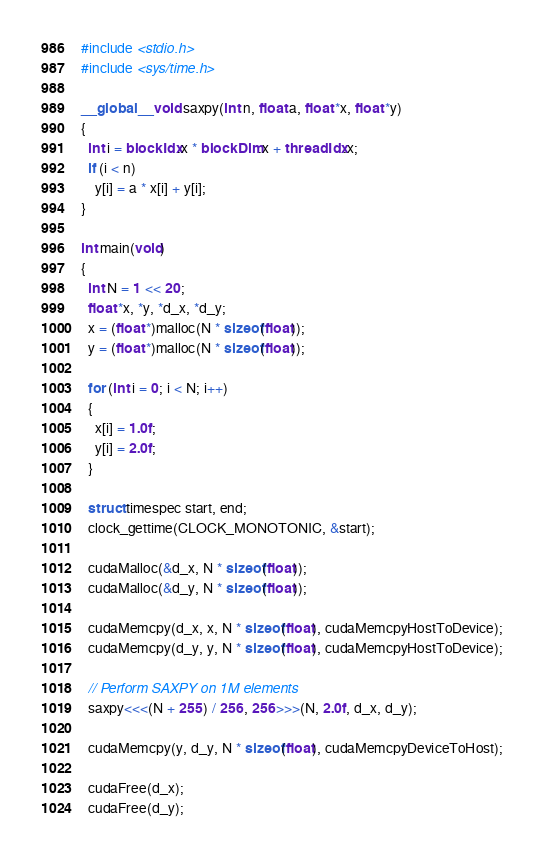<code> <loc_0><loc_0><loc_500><loc_500><_Cuda_>#include <stdio.h>
#include <sys/time.h>

__global__ void saxpy(int n, float a, float *x, float *y)
{
  int i = blockIdx.x * blockDim.x + threadIdx.x;
  if (i < n)
    y[i] = a * x[i] + y[i];
}

int main(void)
{
  int N = 1 << 20;
  float *x, *y, *d_x, *d_y;
  x = (float *)malloc(N * sizeof(float));
  y = (float *)malloc(N * sizeof(float));

  for (int i = 0; i < N; i++)
  {
    x[i] = 1.0f;
    y[i] = 2.0f;
  }

  struct timespec start, end;
  clock_gettime(CLOCK_MONOTONIC, &start);

  cudaMalloc(&d_x, N * sizeof(float));
  cudaMalloc(&d_y, N * sizeof(float));

  cudaMemcpy(d_x, x, N * sizeof(float), cudaMemcpyHostToDevice);
  cudaMemcpy(d_y, y, N * sizeof(float), cudaMemcpyHostToDevice);

  // Perform SAXPY on 1M elements
  saxpy<<<(N + 255) / 256, 256>>>(N, 2.0f, d_x, d_y);

  cudaMemcpy(y, d_y, N * sizeof(float), cudaMemcpyDeviceToHost);

  cudaFree(d_x);
  cudaFree(d_y);
</code> 